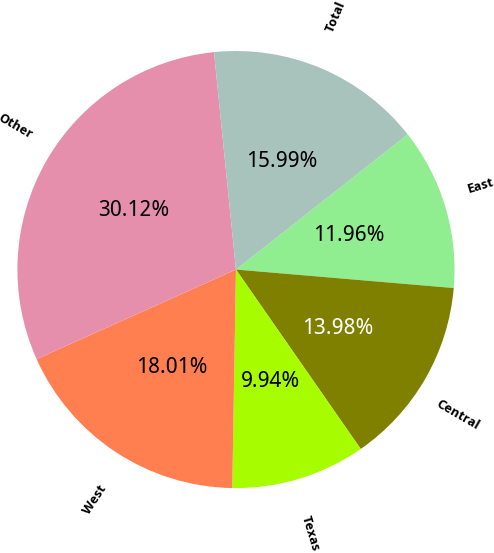Convert chart to OTSL. <chart><loc_0><loc_0><loc_500><loc_500><pie_chart><fcel>East<fcel>Central<fcel>Texas<fcel>West<fcel>Other<fcel>Total<nl><fcel>11.96%<fcel>13.98%<fcel>9.94%<fcel>18.01%<fcel>30.12%<fcel>15.99%<nl></chart> 